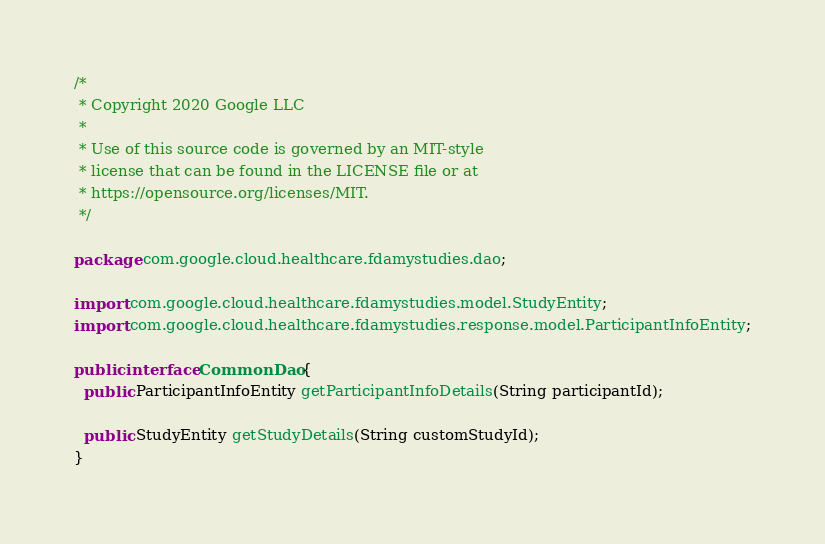<code> <loc_0><loc_0><loc_500><loc_500><_Java_>/*
 * Copyright 2020 Google LLC
 *
 * Use of this source code is governed by an MIT-style
 * license that can be found in the LICENSE file or at
 * https://opensource.org/licenses/MIT.
 */

package com.google.cloud.healthcare.fdamystudies.dao;

import com.google.cloud.healthcare.fdamystudies.model.StudyEntity;
import com.google.cloud.healthcare.fdamystudies.response.model.ParticipantInfoEntity;

public interface CommonDao {
  public ParticipantInfoEntity getParticipantInfoDetails(String participantId);

  public StudyEntity getStudyDetails(String customStudyId);
}
</code> 